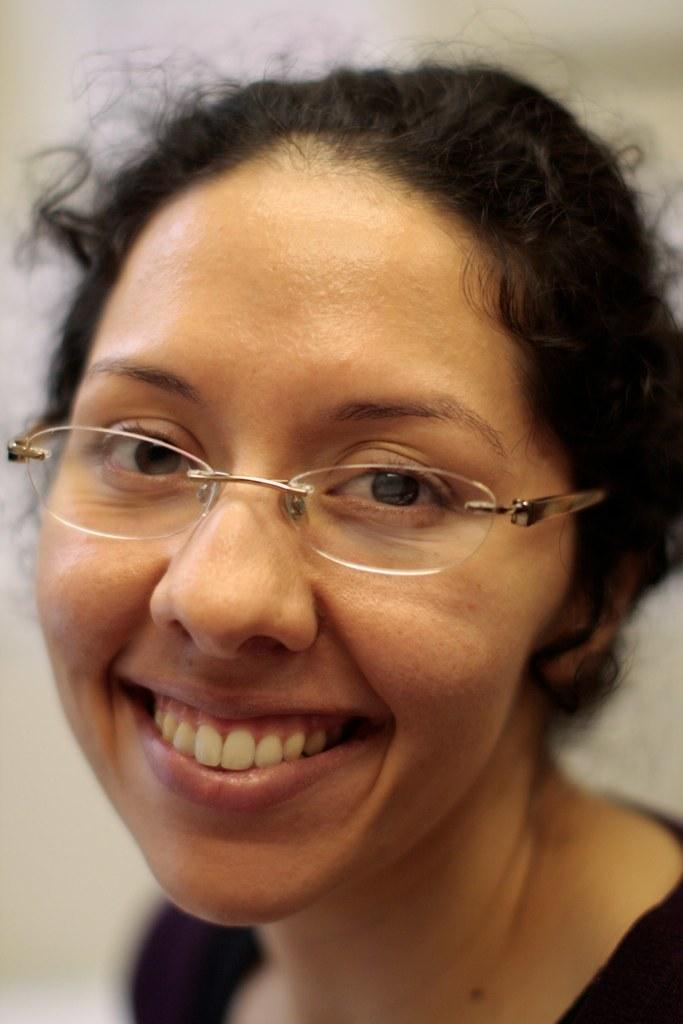Who is the main subject in the image? There is a woman in the image. What is the woman wearing? The woman is wearing a black dress and spectacles. What can be seen in the background of the image? There is a wall in the background of the image. What type of furniture is being moved by the woman in the image? There is no furniture present in the image, and the woman is not shown moving anything. 